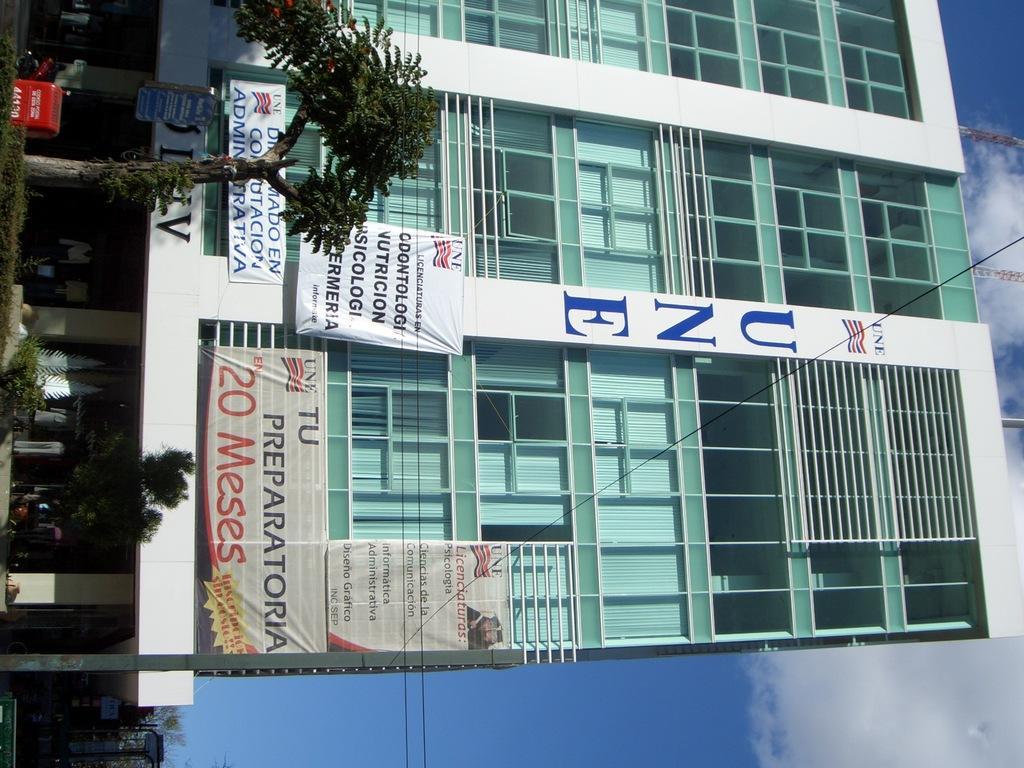Could you give a brief overview of what you see in this image? In the center of the image there is a building and we can see boards. There are trees. In the background there is sky. 